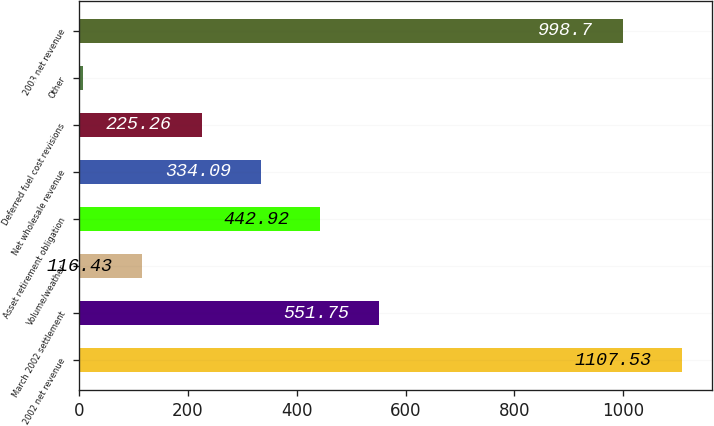Convert chart to OTSL. <chart><loc_0><loc_0><loc_500><loc_500><bar_chart><fcel>2002 net revenue<fcel>March 2002 settlement<fcel>Volume/weather<fcel>Asset retirement obligation<fcel>Net wholesale revenue<fcel>Deferred fuel cost revisions<fcel>Other<fcel>2003 net revenue<nl><fcel>1107.53<fcel>551.75<fcel>116.43<fcel>442.92<fcel>334.09<fcel>225.26<fcel>7.6<fcel>998.7<nl></chart> 